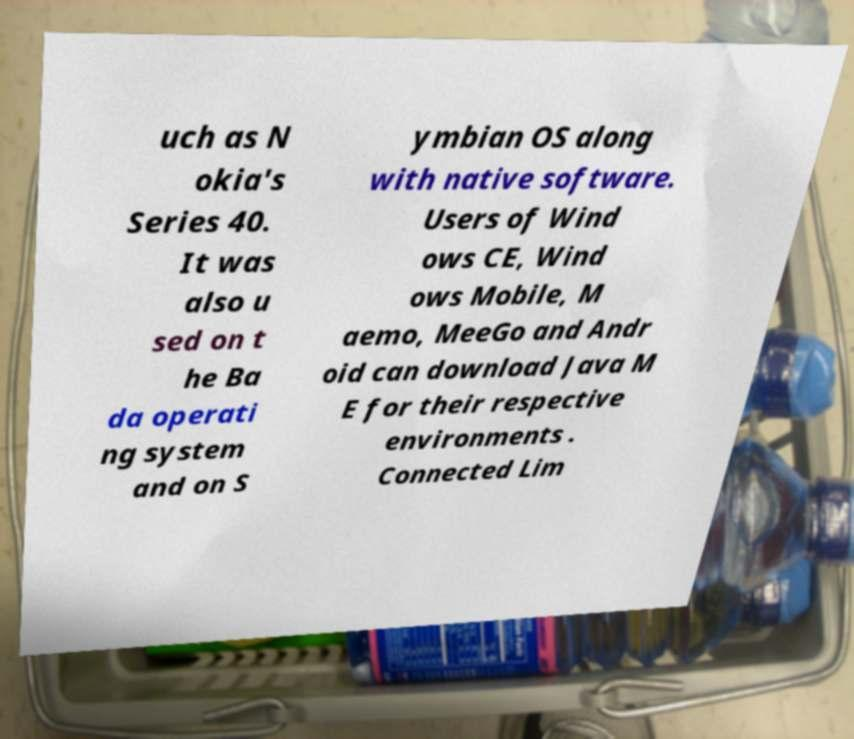Could you assist in decoding the text presented in this image and type it out clearly? uch as N okia's Series 40. It was also u sed on t he Ba da operati ng system and on S ymbian OS along with native software. Users of Wind ows CE, Wind ows Mobile, M aemo, MeeGo and Andr oid can download Java M E for their respective environments . Connected Lim 